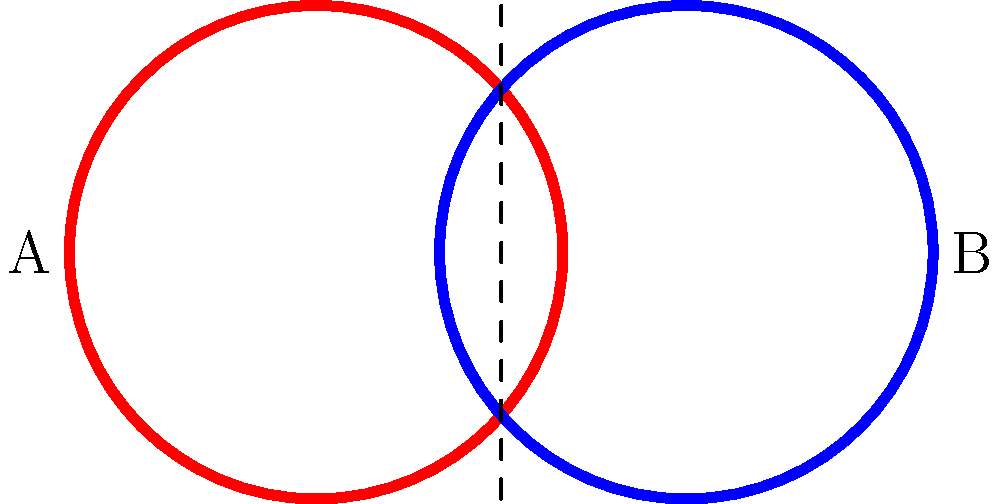In the classic Judas Priest logo, two interlocking chain links form the iconic design. Consider the simplified representation above, where the red link (A) and blue link (B) are connected. If you were to separate these links without breaking them, what is the minimum number of dimensions required for this topological operation? To solve this problem, let's think through the topological properties of the interlocked chain links:

1. In our 3-dimensional world, these links cannot be separated without breaking one of them.

2. The links are essentially closed loops that pass through each other's centers.

3. To separate them without breaking, we need to consider higher dimensions:

   a) In 3D, we can't move one link "through" the other without breaking it.
   
   b) We need an additional dimension to allow one link to "pass through" the other without intersecting.

4. This additional dimension would allow us to move one link "out of" our 3D space momentarily, bypassing the other link, and then back into 3D space.

5. Therefore, we need one dimension more than our regular 3D space.

The concept of using a 4th dimension to solve topological problems like this is reminiscent of how old-school metal bands often pushed boundaries and explored complex themes in their music and imagery.
Answer: 4 dimensions 